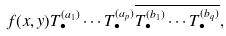Convert formula to latex. <formula><loc_0><loc_0><loc_500><loc_500>f ( x , y ) T _ { \bullet } ^ { ( a _ { 1 } ) } \cdots T _ { \bullet } ^ { ( a _ { p } ) } \overline { T _ { \bullet } ^ { ( b _ { 1 } ) } \cdots T _ { \bullet } ^ { ( b _ { q } ) } } ,</formula> 